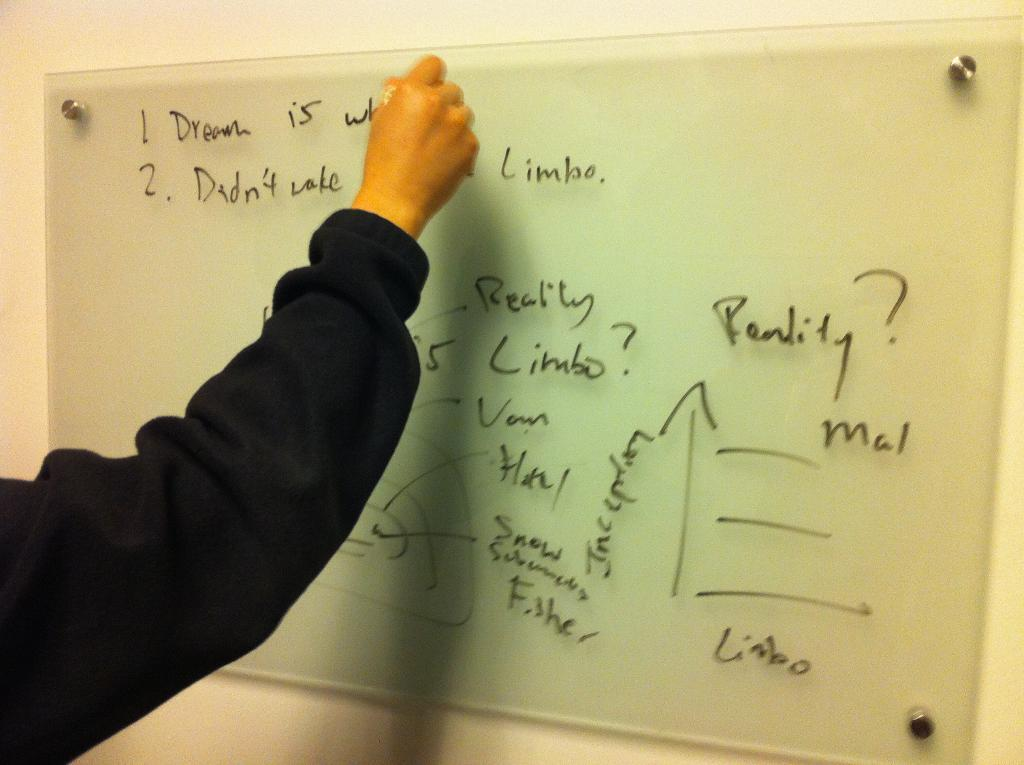<image>
Give a short and clear explanation of the subsequent image. A man writes on a board that discusses dreams and reality. 